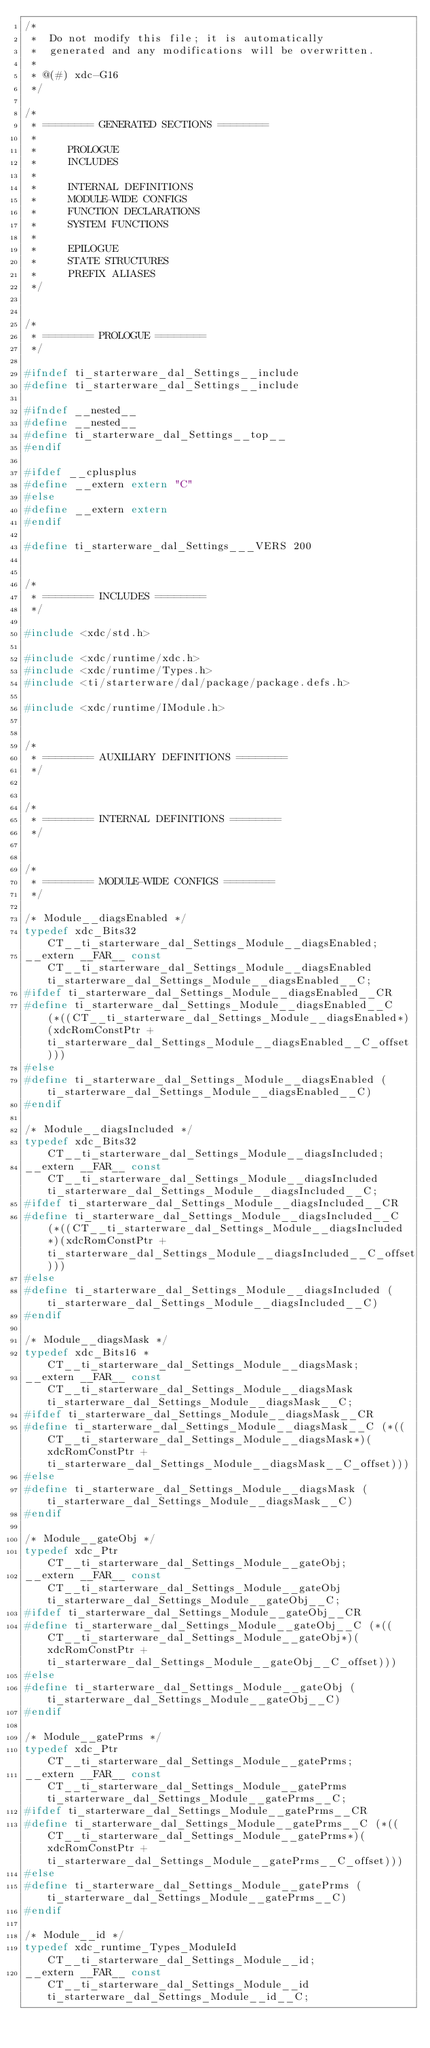Convert code to text. <code><loc_0><loc_0><loc_500><loc_500><_C_>/*
 *  Do not modify this file; it is automatically 
 *  generated and any modifications will be overwritten.
 *
 * @(#) xdc-G16
 */

/*
 * ======== GENERATED SECTIONS ========
 *
 *     PROLOGUE
 *     INCLUDES
 *
 *     INTERNAL DEFINITIONS
 *     MODULE-WIDE CONFIGS
 *     FUNCTION DECLARATIONS
 *     SYSTEM FUNCTIONS
 *
 *     EPILOGUE
 *     STATE STRUCTURES
 *     PREFIX ALIASES
 */


/*
 * ======== PROLOGUE ========
 */

#ifndef ti_starterware_dal_Settings__include
#define ti_starterware_dal_Settings__include

#ifndef __nested__
#define __nested__
#define ti_starterware_dal_Settings__top__
#endif

#ifdef __cplusplus
#define __extern extern "C"
#else
#define __extern extern
#endif

#define ti_starterware_dal_Settings___VERS 200


/*
 * ======== INCLUDES ========
 */

#include <xdc/std.h>

#include <xdc/runtime/xdc.h>
#include <xdc/runtime/Types.h>
#include <ti/starterware/dal/package/package.defs.h>

#include <xdc/runtime/IModule.h>


/*
 * ======== AUXILIARY DEFINITIONS ========
 */


/*
 * ======== INTERNAL DEFINITIONS ========
 */


/*
 * ======== MODULE-WIDE CONFIGS ========
 */

/* Module__diagsEnabled */
typedef xdc_Bits32 CT__ti_starterware_dal_Settings_Module__diagsEnabled;
__extern __FAR__ const CT__ti_starterware_dal_Settings_Module__diagsEnabled ti_starterware_dal_Settings_Module__diagsEnabled__C;
#ifdef ti_starterware_dal_Settings_Module__diagsEnabled__CR
#define ti_starterware_dal_Settings_Module__diagsEnabled__C (*((CT__ti_starterware_dal_Settings_Module__diagsEnabled*)(xdcRomConstPtr + ti_starterware_dal_Settings_Module__diagsEnabled__C_offset)))
#else
#define ti_starterware_dal_Settings_Module__diagsEnabled (ti_starterware_dal_Settings_Module__diagsEnabled__C)
#endif

/* Module__diagsIncluded */
typedef xdc_Bits32 CT__ti_starterware_dal_Settings_Module__diagsIncluded;
__extern __FAR__ const CT__ti_starterware_dal_Settings_Module__diagsIncluded ti_starterware_dal_Settings_Module__diagsIncluded__C;
#ifdef ti_starterware_dal_Settings_Module__diagsIncluded__CR
#define ti_starterware_dal_Settings_Module__diagsIncluded__C (*((CT__ti_starterware_dal_Settings_Module__diagsIncluded*)(xdcRomConstPtr + ti_starterware_dal_Settings_Module__diagsIncluded__C_offset)))
#else
#define ti_starterware_dal_Settings_Module__diagsIncluded (ti_starterware_dal_Settings_Module__diagsIncluded__C)
#endif

/* Module__diagsMask */
typedef xdc_Bits16 *CT__ti_starterware_dal_Settings_Module__diagsMask;
__extern __FAR__ const CT__ti_starterware_dal_Settings_Module__diagsMask ti_starterware_dal_Settings_Module__diagsMask__C;
#ifdef ti_starterware_dal_Settings_Module__diagsMask__CR
#define ti_starterware_dal_Settings_Module__diagsMask__C (*((CT__ti_starterware_dal_Settings_Module__diagsMask*)(xdcRomConstPtr + ti_starterware_dal_Settings_Module__diagsMask__C_offset)))
#else
#define ti_starterware_dal_Settings_Module__diagsMask (ti_starterware_dal_Settings_Module__diagsMask__C)
#endif

/* Module__gateObj */
typedef xdc_Ptr CT__ti_starterware_dal_Settings_Module__gateObj;
__extern __FAR__ const CT__ti_starterware_dal_Settings_Module__gateObj ti_starterware_dal_Settings_Module__gateObj__C;
#ifdef ti_starterware_dal_Settings_Module__gateObj__CR
#define ti_starterware_dal_Settings_Module__gateObj__C (*((CT__ti_starterware_dal_Settings_Module__gateObj*)(xdcRomConstPtr + ti_starterware_dal_Settings_Module__gateObj__C_offset)))
#else
#define ti_starterware_dal_Settings_Module__gateObj (ti_starterware_dal_Settings_Module__gateObj__C)
#endif

/* Module__gatePrms */
typedef xdc_Ptr CT__ti_starterware_dal_Settings_Module__gatePrms;
__extern __FAR__ const CT__ti_starterware_dal_Settings_Module__gatePrms ti_starterware_dal_Settings_Module__gatePrms__C;
#ifdef ti_starterware_dal_Settings_Module__gatePrms__CR
#define ti_starterware_dal_Settings_Module__gatePrms__C (*((CT__ti_starterware_dal_Settings_Module__gatePrms*)(xdcRomConstPtr + ti_starterware_dal_Settings_Module__gatePrms__C_offset)))
#else
#define ti_starterware_dal_Settings_Module__gatePrms (ti_starterware_dal_Settings_Module__gatePrms__C)
#endif

/* Module__id */
typedef xdc_runtime_Types_ModuleId CT__ti_starterware_dal_Settings_Module__id;
__extern __FAR__ const CT__ti_starterware_dal_Settings_Module__id ti_starterware_dal_Settings_Module__id__C;</code> 